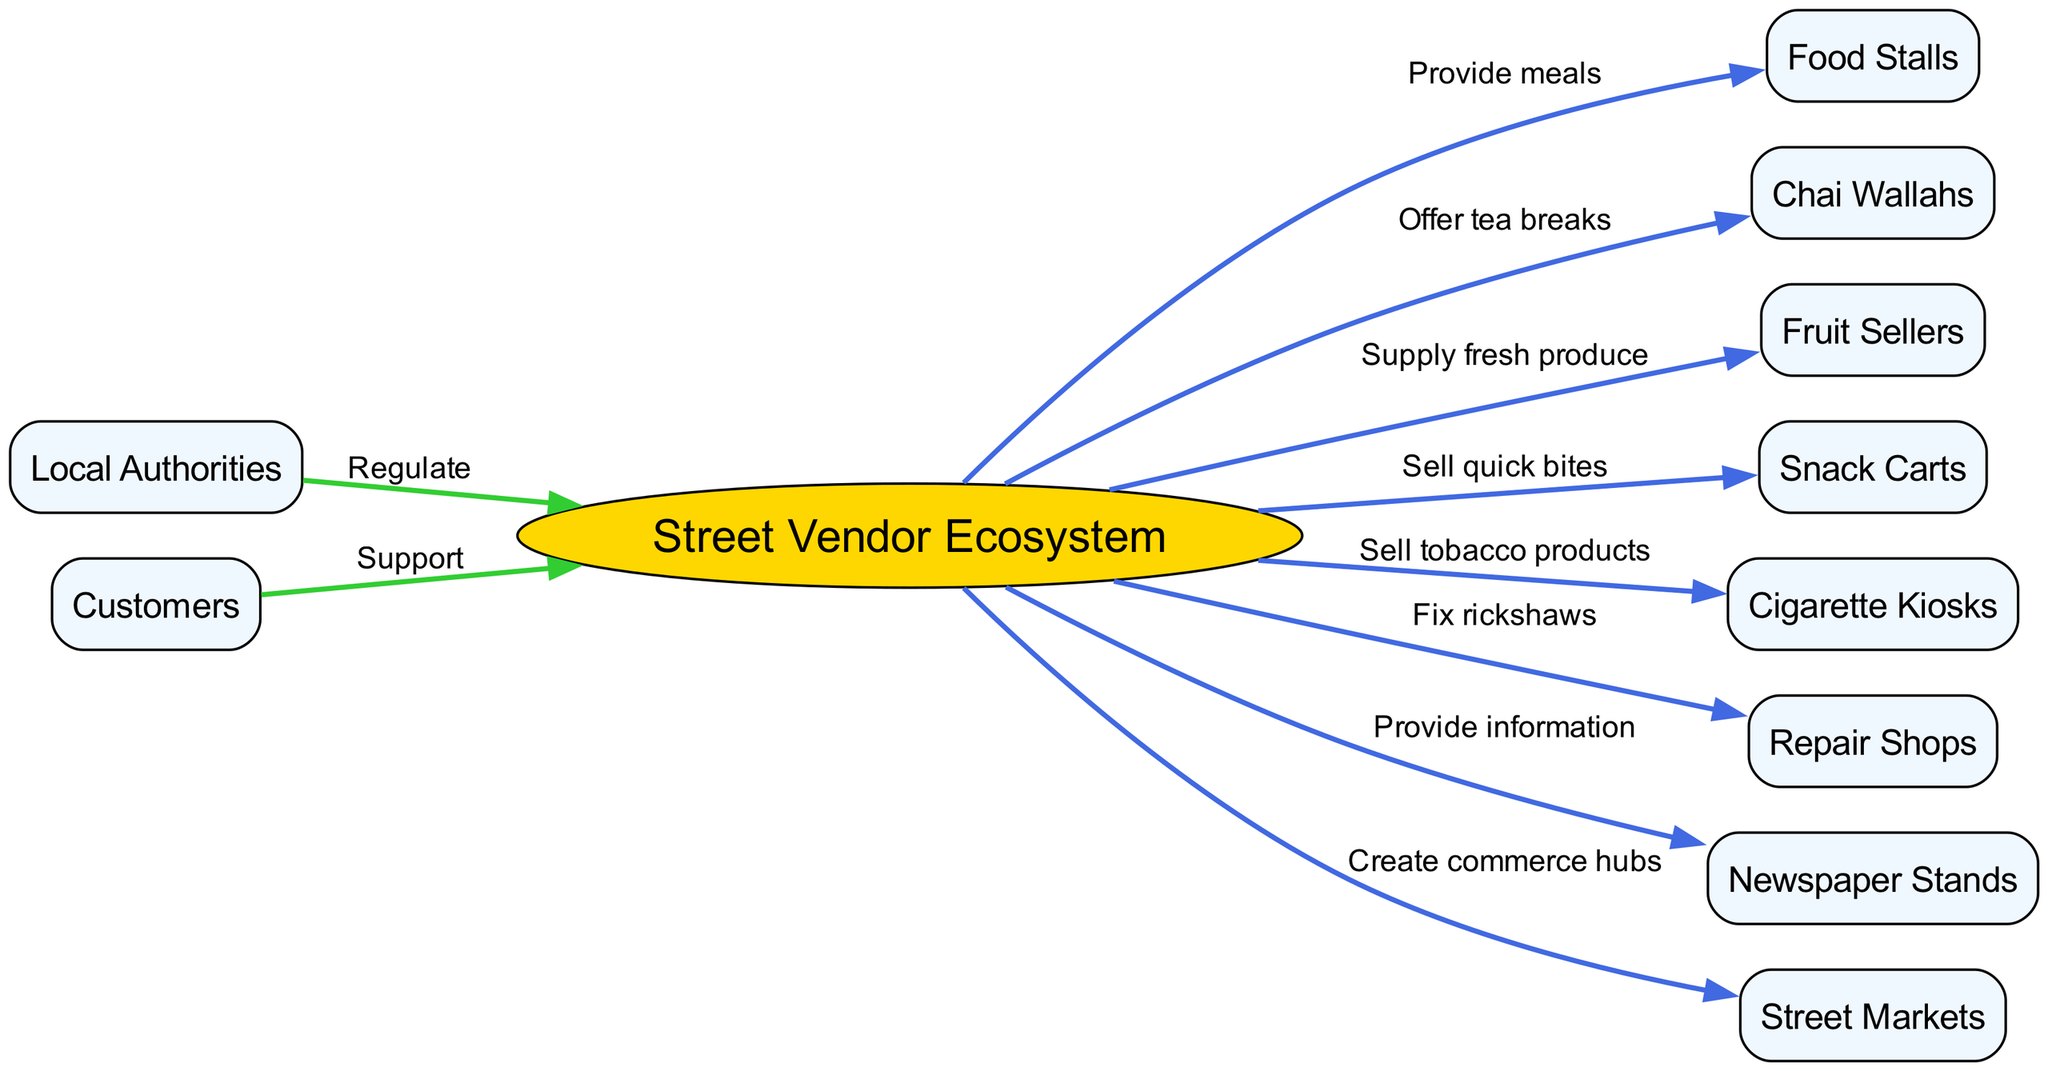What is the central concept of the diagram? The central concept, highlighted in the diagram, represents the primary focus of the map and acts as the starting point for all connected nodes. In this case, it is labeled "Street Vendor Ecosystem."
Answer: Street Vendor Ecosystem How many types of vendors are represented in the diagram? By counting the individual nodes that represent the different types of vendors in the "Street Vendor Ecosystem," there are a total of eight distinct types listed, including food stalls, chai wallahs, fruit sellers, snack carts, cigarette kiosks, and more.
Answer: Eight What do Chai Wallahs offer? The relationship indicated on the diagram shows that Chai Wallahs have the specific function of providing tea breaks to customers, as stated in the connecting label.
Answer: Offer tea breaks What is the role of Local Authorities in this ecosystem? The diagram establishes a connection from "Local Authorities" to the "Street Vendor Ecosystem" with a label indicating a regulatory function, highlighting their responsibility in overseeing or controlling the activities within the vending ecosystem.
Answer: Regulate Which vendor type is linked to fixing rickshaws? The connection labeled in the diagram specifies that Repair Shops play a role in fixing rickshaws, which is a critical service for rickshaw pullers and related operations.
Answer: Repair Shops How do Customers interact with the Street Vendor Ecosystem? The diagram shows a direct relationship where customers support the street vendor ecosystem, emphasizing their role as patrons who contribute to its sustainability by purchasing goods and services from the vendors.
Answer: Support What do Fruit Sellers supply? According to the diagram, the label connecting Fruit Sellers to the "Street Vendor Ecosystem" clearly indicates that they provide fresh produce, which is an essential offering in the area.
Answer: Supply fresh produce Which vendor type creates commerce hubs? The diagram highlights that Street Markets are responsible for creating commerce hubs, which are essential for gathering various vendors and attracting customers in a central location.
Answer: Street Markets What do Cigarette Kiosks sell? The diagram specifies the function of Cigarette Kiosks, which is to sell tobacco products according to the label connecting them to the central concept of the ecosystem.
Answer: Sell tobacco products 